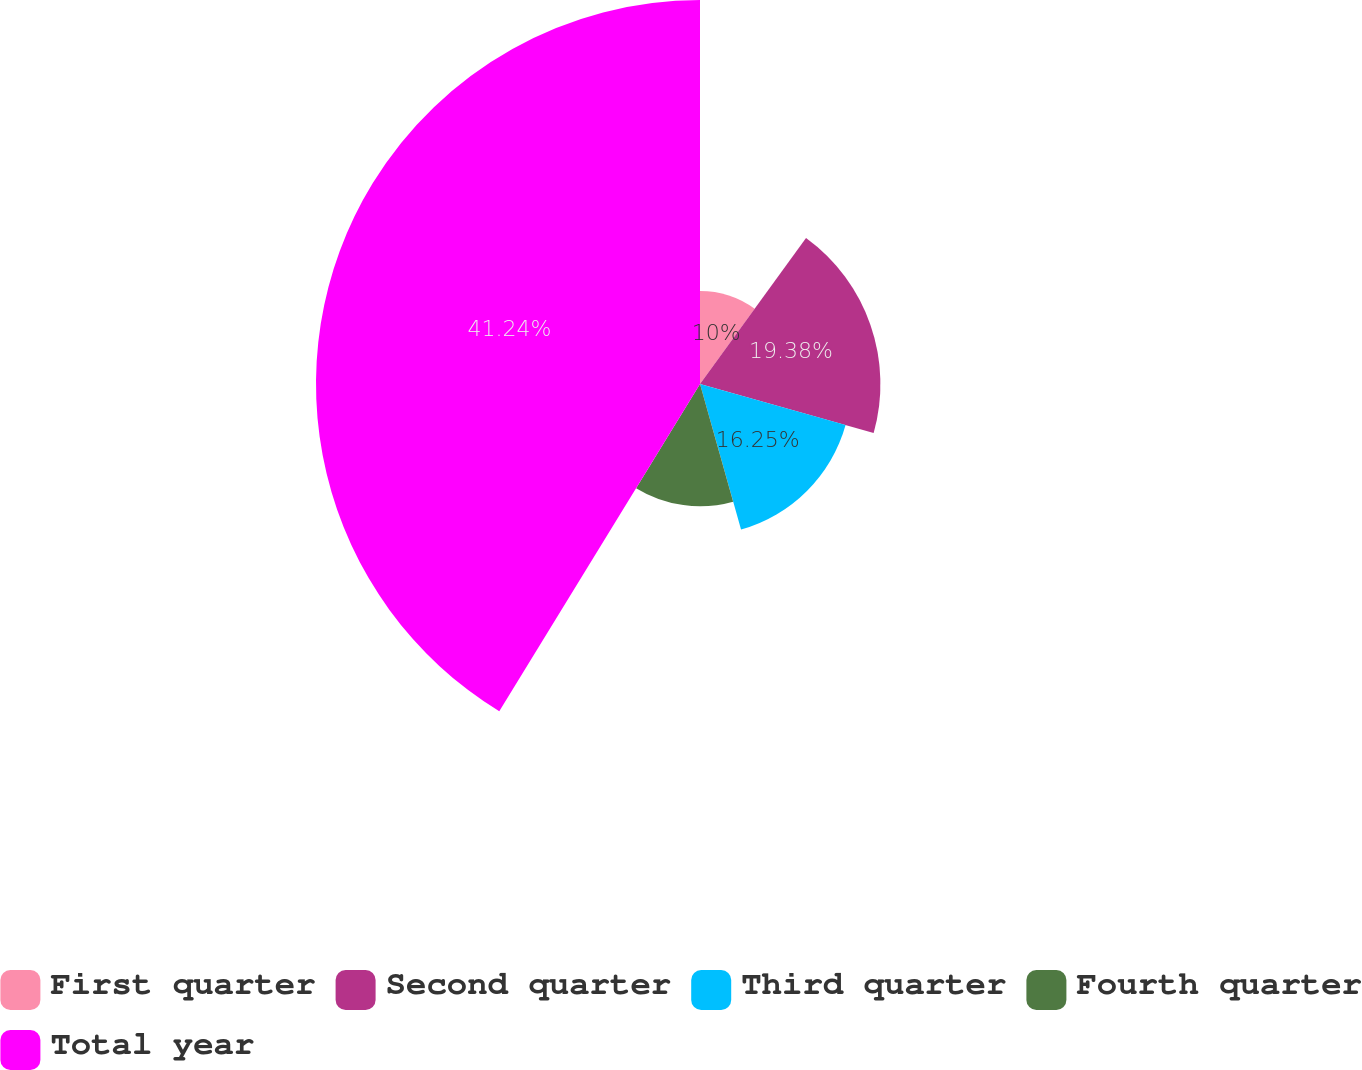<chart> <loc_0><loc_0><loc_500><loc_500><pie_chart><fcel>First quarter<fcel>Second quarter<fcel>Third quarter<fcel>Fourth quarter<fcel>Total year<nl><fcel>10.0%<fcel>19.38%<fcel>16.25%<fcel>13.13%<fcel>41.25%<nl></chart> 